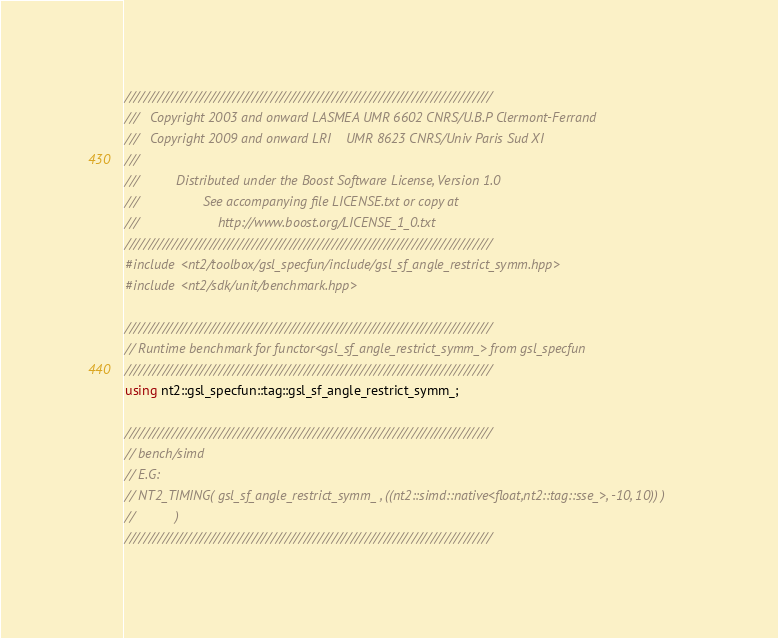<code> <loc_0><loc_0><loc_500><loc_500><_C++_>//////////////////////////////////////////////////////////////////////////////
///   Copyright 2003 and onward LASMEA UMR 6602 CNRS/U.B.P Clermont-Ferrand
///   Copyright 2009 and onward LRI    UMR 8623 CNRS/Univ Paris Sud XI
///
///          Distributed under the Boost Software License, Version 1.0
///                 See accompanying file LICENSE.txt or copy at
///                     http://www.boost.org/LICENSE_1_0.txt
//////////////////////////////////////////////////////////////////////////////
#include <nt2/toolbox/gsl_specfun/include/gsl_sf_angle_restrict_symm.hpp>
#include <nt2/sdk/unit/benchmark.hpp>

//////////////////////////////////////////////////////////////////////////////
// Runtime benchmark for functor<gsl_sf_angle_restrict_symm_> from gsl_specfun
//////////////////////////////////////////////////////////////////////////////
using nt2::gsl_specfun::tag::gsl_sf_angle_restrict_symm_;

//////////////////////////////////////////////////////////////////////////////
// bench/simd
// E.G:
// NT2_TIMING( gsl_sf_angle_restrict_symm_ , ((nt2::simd::native<float,nt2::tag::sse_>, -10, 10)) ) 
//           )
//////////////////////////////////////////////////////////////////////////////
</code> 